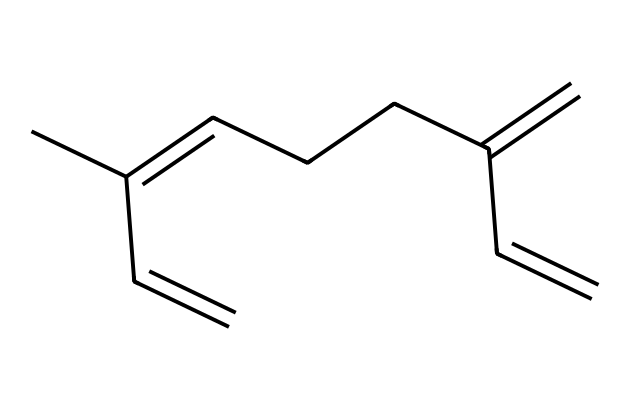What is the molecular formula of myrcene? To determine the molecular formula, we need to analyze the number of each type of atom present in the SMILES representation. The formula can be derived from the structure that shows the presence of 10 carbon atoms and 16 hydrogen atoms.
Answer: C10H16 How many double bonds are in myrcene? By examining the structure detailed in the SMILES representation, we can identify that there are three double bonds present in the molecule.
Answer: 3 What type of compound is myrcene? Myrcene is classified as a terpene based on its structural features, which include multiple alkene (double bond) functionalities characteristic of terpenoids.
Answer: terpene What is the functional group in myrcene? The presence of carbon-carbon double bonds indicates that myrcene's functional groups are alkenes, which are a type of unsaturated hydrocarbon.
Answer: alkene Is myrcene a saturated or unsaturated compound? By identifying the three double bonds in myrcene, we can conclude that it is unsaturated, as unsaturation refers to the presence of double or triple bonds.
Answer: unsaturated 